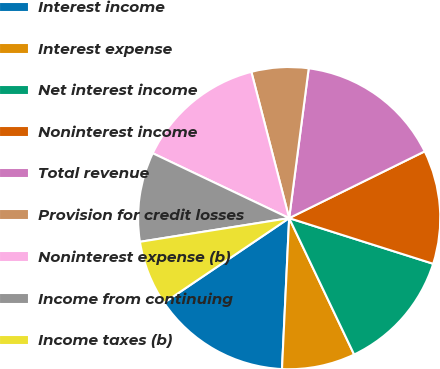Convert chart to OTSL. <chart><loc_0><loc_0><loc_500><loc_500><pie_chart><fcel>Interest income<fcel>Interest expense<fcel>Net interest income<fcel>Noninterest income<fcel>Total revenue<fcel>Provision for credit losses<fcel>Noninterest expense (b)<fcel>Income from continuing<fcel>Income taxes (b)<nl><fcel>14.78%<fcel>7.83%<fcel>13.04%<fcel>12.17%<fcel>15.65%<fcel>6.09%<fcel>13.91%<fcel>9.57%<fcel>6.96%<nl></chart> 